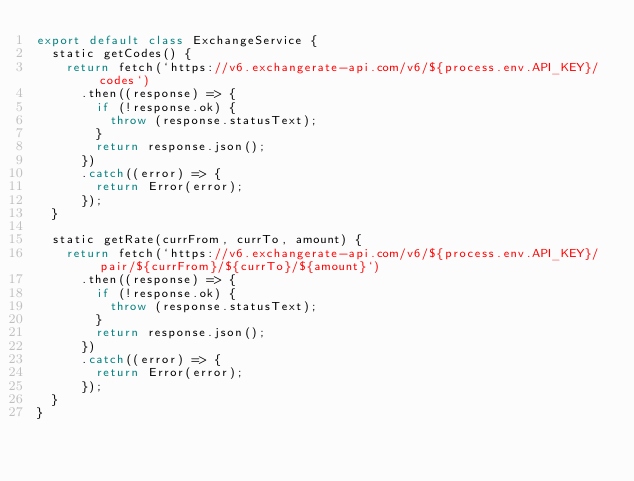Convert code to text. <code><loc_0><loc_0><loc_500><loc_500><_JavaScript_>export default class ExchangeService {
  static getCodes() {
    return fetch(`https://v6.exchangerate-api.com/v6/${process.env.API_KEY}/codes`)
      .then((response) => {
        if (!response.ok) {
          throw (response.statusText);
        }
        return response.json();
      })
      .catch((error) => {
        return Error(error);
      });
  }

  static getRate(currFrom, currTo, amount) {
    return fetch(`https://v6.exchangerate-api.com/v6/${process.env.API_KEY}/pair/${currFrom}/${currTo}/${amount}`)
      .then((response) => {
        if (!response.ok) {
          throw (response.statusText);
        }
        return response.json();
      })
      .catch((error) => {
        return Error(error);
      });
  }
}</code> 